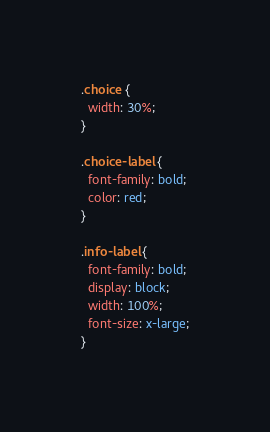<code> <loc_0><loc_0><loc_500><loc_500><_CSS_>.choice {
  width: 30%;
}

.choice-label {
  font-family: bold;
  color: red;
}

.info-label {
  font-family: bold;
  display: block;
  width: 100%;
  font-size: x-large;
}
</code> 